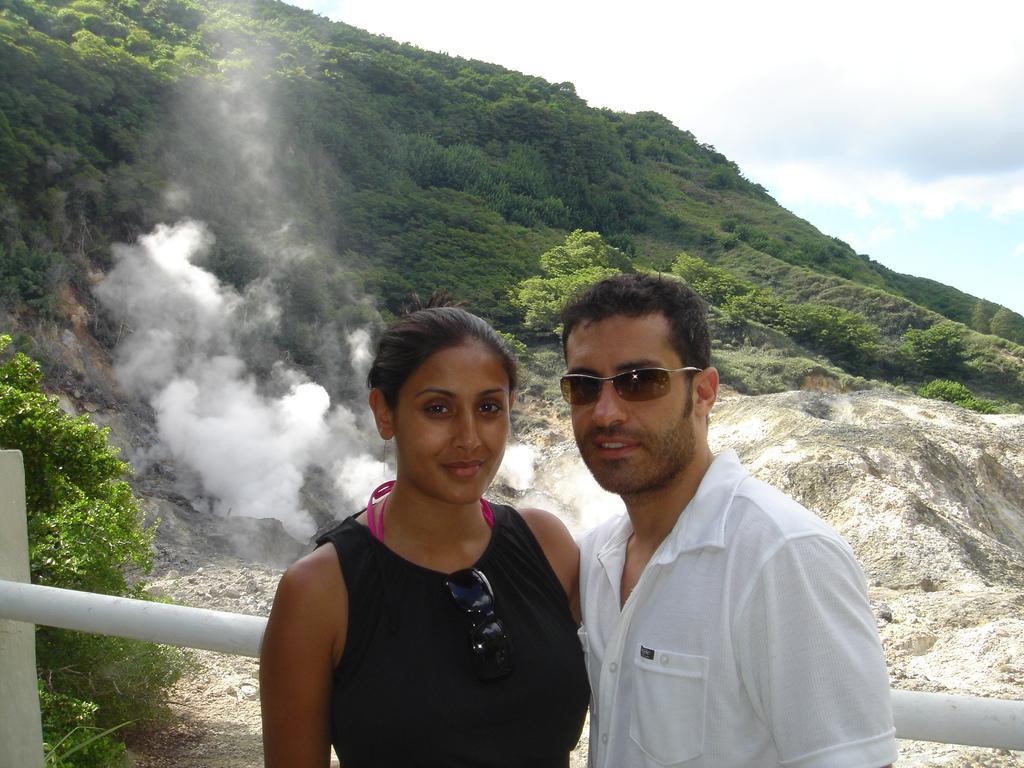Please provide a concise description of this image. In the middle of the image two persons are standing and smiling. Behind them there is fencing. Behind the fencing there are some trees on a hill and we can see smoke on the hill. At the top of the image there are some clouds in the sky. 